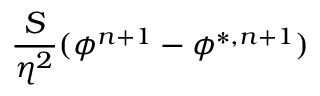Convert formula to latex. <formula><loc_0><loc_0><loc_500><loc_500>\frac { S } { \eta ^ { 2 } } ( \phi ^ { n + 1 } - \phi ^ { * , n + 1 } )</formula> 